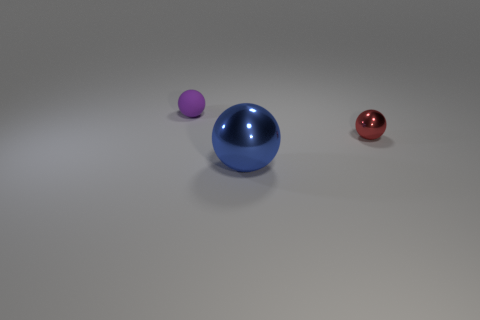Is there another red object that has the same shape as the large thing?
Provide a succinct answer. Yes. What number of tiny red metallic objects are there?
Keep it short and to the point. 1. Are the small object right of the purple sphere and the big blue sphere made of the same material?
Offer a very short reply. Yes. Is there a matte sphere that has the same size as the red thing?
Your answer should be very brief. Yes. Is the shape of the tiny metallic thing the same as the thing that is on the left side of the big blue object?
Make the answer very short. Yes. Is there a thing on the left side of the tiny sphere behind the small thing that is in front of the small purple object?
Offer a terse response. No. How big is the purple object?
Your answer should be very brief. Small. Does the metallic thing that is on the right side of the blue sphere have the same shape as the large blue thing?
Provide a succinct answer. Yes. What is the color of the tiny matte thing that is the same shape as the large object?
Keep it short and to the point. Purple. Is there any other thing that is made of the same material as the large sphere?
Ensure brevity in your answer.  Yes. 